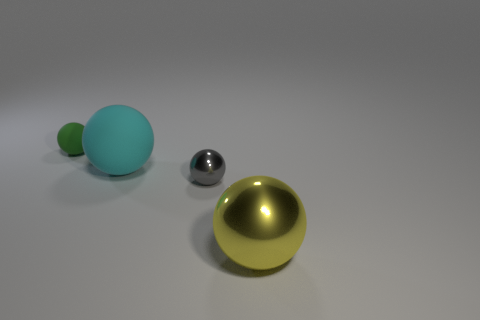Subtract all cyan spheres. Subtract all green cylinders. How many spheres are left? 3 Add 3 cyan rubber things. How many objects exist? 7 Add 2 big purple shiny spheres. How many big purple shiny spheres exist? 2 Subtract 1 green balls. How many objects are left? 3 Subtract all yellow things. Subtract all gray things. How many objects are left? 2 Add 2 cyan rubber things. How many cyan rubber things are left? 3 